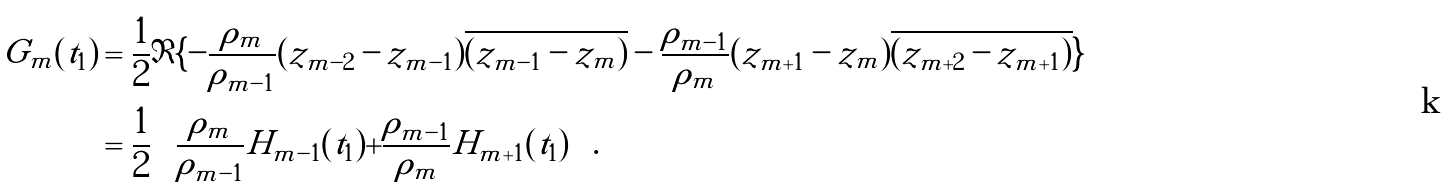<formula> <loc_0><loc_0><loc_500><loc_500>G _ { m } ( t _ { 1 } ) & = \frac { 1 } { 2 } \Im \{ - \frac { \rho _ { m } } { \rho _ { m - 1 } } ( z _ { m - 2 } - z _ { m - 1 } ) \overline { ( z _ { m - 1 } - z _ { m } ) } - \frac { \rho _ { m - 1 } } { \rho _ { m } } ( z _ { m + 1 } - z _ { m } ) \overline { ( z _ { m + 2 } - z _ { m + 1 } ) } \} \\ & = \frac { 1 } { 2 } \left ( \frac { \rho _ { m } } { \rho _ { m - 1 } } H _ { m - 1 } ( t _ { 1 } ) + \frac { \rho _ { m - 1 } } { \rho _ { m } } H _ { m + 1 } ( t _ { 1 } ) \right ) .</formula> 